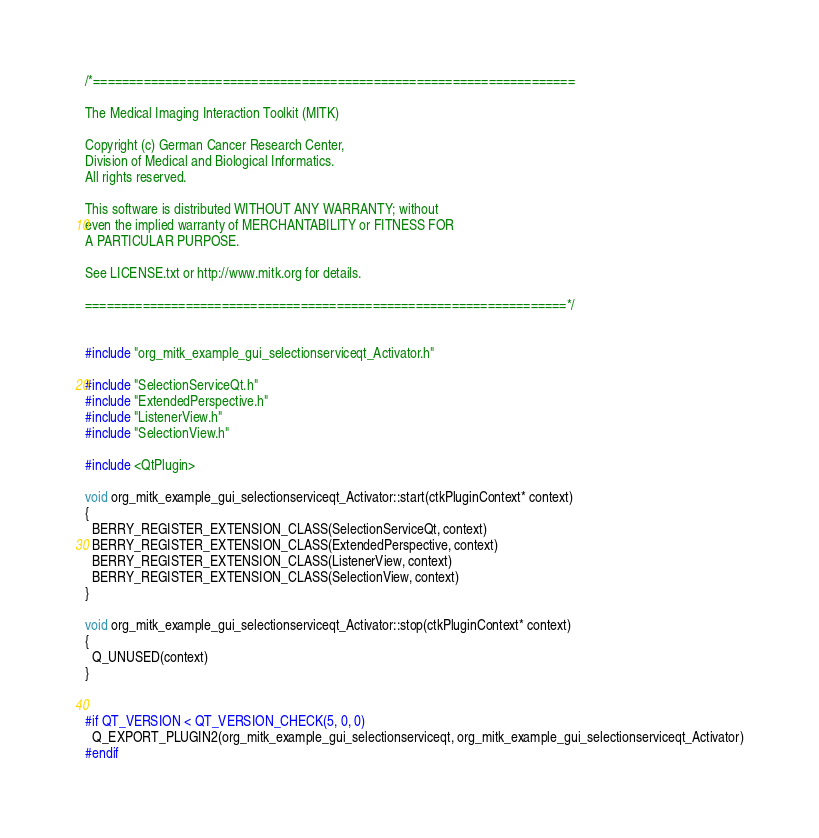Convert code to text. <code><loc_0><loc_0><loc_500><loc_500><_C++_>/*===================================================================

The Medical Imaging Interaction Toolkit (MITK)

Copyright (c) German Cancer Research Center,
Division of Medical and Biological Informatics.
All rights reserved.

This software is distributed WITHOUT ANY WARRANTY; without
even the implied warranty of MERCHANTABILITY or FITNESS FOR
A PARTICULAR PURPOSE.

See LICENSE.txt or http://www.mitk.org for details.

===================================================================*/


#include "org_mitk_example_gui_selectionserviceqt_Activator.h"

#include "SelectionServiceQt.h"
#include "ExtendedPerspective.h"
#include "ListenerView.h"
#include "SelectionView.h"

#include <QtPlugin>

void org_mitk_example_gui_selectionserviceqt_Activator::start(ctkPluginContext* context)
{
  BERRY_REGISTER_EXTENSION_CLASS(SelectionServiceQt, context)
  BERRY_REGISTER_EXTENSION_CLASS(ExtendedPerspective, context)
  BERRY_REGISTER_EXTENSION_CLASS(ListenerView, context)
  BERRY_REGISTER_EXTENSION_CLASS(SelectionView, context)
}

void org_mitk_example_gui_selectionserviceqt_Activator::stop(ctkPluginContext* context)
{
  Q_UNUSED(context)
}


#if QT_VERSION < QT_VERSION_CHECK(5, 0, 0)
  Q_EXPORT_PLUGIN2(org_mitk_example_gui_selectionserviceqt, org_mitk_example_gui_selectionserviceqt_Activator)
#endif
</code> 